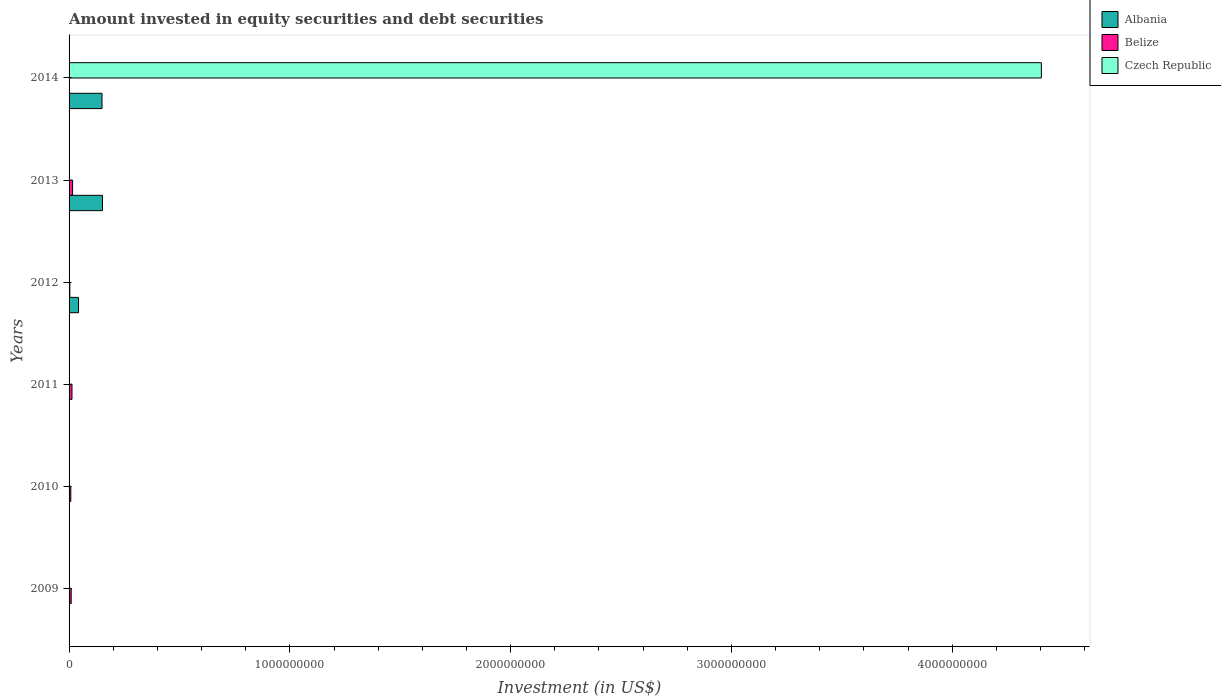Are the number of bars per tick equal to the number of legend labels?
Keep it short and to the point. No. Are the number of bars on each tick of the Y-axis equal?
Ensure brevity in your answer.  No. How many bars are there on the 1st tick from the top?
Make the answer very short. 3. How many bars are there on the 5th tick from the bottom?
Your answer should be compact. 2. What is the label of the 2nd group of bars from the top?
Provide a succinct answer. 2013. What is the amount invested in equity securities and debt securities in Belize in 2011?
Your response must be concise. 1.32e+07. Across all years, what is the maximum amount invested in equity securities and debt securities in Czech Republic?
Provide a succinct answer. 4.40e+09. In which year was the amount invested in equity securities and debt securities in Belize maximum?
Make the answer very short. 2013. What is the total amount invested in equity securities and debt securities in Belize in the graph?
Your answer should be compact. 5.00e+07. What is the difference between the amount invested in equity securities and debt securities in Belize in 2009 and that in 2010?
Your answer should be compact. 1.84e+06. What is the difference between the amount invested in equity securities and debt securities in Albania in 2011 and the amount invested in equity securities and debt securities in Czech Republic in 2013?
Offer a very short reply. 0. What is the average amount invested in equity securities and debt securities in Belize per year?
Offer a very short reply. 8.34e+06. In the year 2014, what is the difference between the amount invested in equity securities and debt securities in Albania and amount invested in equity securities and debt securities in Belize?
Offer a very short reply. 1.49e+08. What is the ratio of the amount invested in equity securities and debt securities in Belize in 2009 to that in 2010?
Provide a succinct answer. 1.24. What is the difference between the highest and the second highest amount invested in equity securities and debt securities in Albania?
Your response must be concise. 2.23e+06. What is the difference between the highest and the lowest amount invested in equity securities and debt securities in Belize?
Give a very brief answer. 1.59e+07. How many years are there in the graph?
Provide a succinct answer. 6. Are the values on the major ticks of X-axis written in scientific E-notation?
Ensure brevity in your answer.  No. Does the graph contain grids?
Make the answer very short. No. How are the legend labels stacked?
Give a very brief answer. Vertical. What is the title of the graph?
Make the answer very short. Amount invested in equity securities and debt securities. Does "Tunisia" appear as one of the legend labels in the graph?
Your answer should be compact. No. What is the label or title of the X-axis?
Make the answer very short. Investment (in US$). What is the Investment (in US$) in Belize in 2009?
Your response must be concise. 9.65e+06. What is the Investment (in US$) of Belize in 2010?
Make the answer very short. 7.81e+06. What is the Investment (in US$) of Czech Republic in 2010?
Ensure brevity in your answer.  0. What is the Investment (in US$) in Belize in 2011?
Make the answer very short. 1.32e+07. What is the Investment (in US$) in Albania in 2012?
Your answer should be compact. 4.29e+07. What is the Investment (in US$) of Belize in 2012?
Offer a terse response. 3.43e+06. What is the Investment (in US$) in Czech Republic in 2012?
Your answer should be very brief. 0. What is the Investment (in US$) of Albania in 2013?
Give a very brief answer. 1.51e+08. What is the Investment (in US$) in Belize in 2013?
Your answer should be very brief. 1.59e+07. What is the Investment (in US$) of Albania in 2014?
Your answer should be compact. 1.49e+08. What is the Investment (in US$) of Belize in 2014?
Your answer should be very brief. 430.6. What is the Investment (in US$) in Czech Republic in 2014?
Ensure brevity in your answer.  4.40e+09. Across all years, what is the maximum Investment (in US$) of Albania?
Offer a very short reply. 1.51e+08. Across all years, what is the maximum Investment (in US$) in Belize?
Your response must be concise. 1.59e+07. Across all years, what is the maximum Investment (in US$) of Czech Republic?
Your answer should be compact. 4.40e+09. Across all years, what is the minimum Investment (in US$) in Belize?
Your response must be concise. 430.6. Across all years, what is the minimum Investment (in US$) of Czech Republic?
Make the answer very short. 0. What is the total Investment (in US$) in Albania in the graph?
Ensure brevity in your answer.  3.44e+08. What is the total Investment (in US$) of Belize in the graph?
Ensure brevity in your answer.  5.00e+07. What is the total Investment (in US$) in Czech Republic in the graph?
Your response must be concise. 4.40e+09. What is the difference between the Investment (in US$) of Belize in 2009 and that in 2010?
Your answer should be very brief. 1.84e+06. What is the difference between the Investment (in US$) of Belize in 2009 and that in 2011?
Keep it short and to the point. -3.54e+06. What is the difference between the Investment (in US$) in Belize in 2009 and that in 2012?
Provide a succinct answer. 6.23e+06. What is the difference between the Investment (in US$) in Belize in 2009 and that in 2013?
Your answer should be very brief. -6.26e+06. What is the difference between the Investment (in US$) in Belize in 2009 and that in 2014?
Provide a short and direct response. 9.65e+06. What is the difference between the Investment (in US$) of Belize in 2010 and that in 2011?
Ensure brevity in your answer.  -5.38e+06. What is the difference between the Investment (in US$) of Belize in 2010 and that in 2012?
Give a very brief answer. 4.39e+06. What is the difference between the Investment (in US$) of Belize in 2010 and that in 2013?
Offer a very short reply. -8.10e+06. What is the difference between the Investment (in US$) of Belize in 2010 and that in 2014?
Ensure brevity in your answer.  7.81e+06. What is the difference between the Investment (in US$) in Belize in 2011 and that in 2012?
Make the answer very short. 9.77e+06. What is the difference between the Investment (in US$) in Belize in 2011 and that in 2013?
Give a very brief answer. -2.72e+06. What is the difference between the Investment (in US$) in Belize in 2011 and that in 2014?
Offer a terse response. 1.32e+07. What is the difference between the Investment (in US$) in Albania in 2012 and that in 2013?
Provide a succinct answer. -1.08e+08. What is the difference between the Investment (in US$) of Belize in 2012 and that in 2013?
Your answer should be very brief. -1.25e+07. What is the difference between the Investment (in US$) of Albania in 2012 and that in 2014?
Give a very brief answer. -1.06e+08. What is the difference between the Investment (in US$) of Belize in 2012 and that in 2014?
Provide a short and direct response. 3.43e+06. What is the difference between the Investment (in US$) in Albania in 2013 and that in 2014?
Give a very brief answer. 2.23e+06. What is the difference between the Investment (in US$) of Belize in 2013 and that in 2014?
Give a very brief answer. 1.59e+07. What is the difference between the Investment (in US$) of Belize in 2009 and the Investment (in US$) of Czech Republic in 2014?
Offer a terse response. -4.39e+09. What is the difference between the Investment (in US$) in Belize in 2010 and the Investment (in US$) in Czech Republic in 2014?
Ensure brevity in your answer.  -4.40e+09. What is the difference between the Investment (in US$) of Belize in 2011 and the Investment (in US$) of Czech Republic in 2014?
Offer a terse response. -4.39e+09. What is the difference between the Investment (in US$) in Albania in 2012 and the Investment (in US$) in Belize in 2013?
Give a very brief answer. 2.70e+07. What is the difference between the Investment (in US$) of Albania in 2012 and the Investment (in US$) of Belize in 2014?
Make the answer very short. 4.29e+07. What is the difference between the Investment (in US$) of Albania in 2012 and the Investment (in US$) of Czech Republic in 2014?
Make the answer very short. -4.36e+09. What is the difference between the Investment (in US$) of Belize in 2012 and the Investment (in US$) of Czech Republic in 2014?
Give a very brief answer. -4.40e+09. What is the difference between the Investment (in US$) in Albania in 2013 and the Investment (in US$) in Belize in 2014?
Your response must be concise. 1.51e+08. What is the difference between the Investment (in US$) in Albania in 2013 and the Investment (in US$) in Czech Republic in 2014?
Your response must be concise. -4.25e+09. What is the difference between the Investment (in US$) of Belize in 2013 and the Investment (in US$) of Czech Republic in 2014?
Provide a succinct answer. -4.39e+09. What is the average Investment (in US$) in Albania per year?
Keep it short and to the point. 5.73e+07. What is the average Investment (in US$) in Belize per year?
Provide a succinct answer. 8.34e+06. What is the average Investment (in US$) of Czech Republic per year?
Your answer should be very brief. 7.34e+08. In the year 2012, what is the difference between the Investment (in US$) in Albania and Investment (in US$) in Belize?
Keep it short and to the point. 3.95e+07. In the year 2013, what is the difference between the Investment (in US$) of Albania and Investment (in US$) of Belize?
Give a very brief answer. 1.35e+08. In the year 2014, what is the difference between the Investment (in US$) in Albania and Investment (in US$) in Belize?
Offer a terse response. 1.49e+08. In the year 2014, what is the difference between the Investment (in US$) in Albania and Investment (in US$) in Czech Republic?
Your answer should be compact. -4.25e+09. In the year 2014, what is the difference between the Investment (in US$) of Belize and Investment (in US$) of Czech Republic?
Ensure brevity in your answer.  -4.40e+09. What is the ratio of the Investment (in US$) in Belize in 2009 to that in 2010?
Offer a very short reply. 1.24. What is the ratio of the Investment (in US$) of Belize in 2009 to that in 2011?
Keep it short and to the point. 0.73. What is the ratio of the Investment (in US$) in Belize in 2009 to that in 2012?
Ensure brevity in your answer.  2.82. What is the ratio of the Investment (in US$) of Belize in 2009 to that in 2013?
Your answer should be compact. 0.61. What is the ratio of the Investment (in US$) of Belize in 2009 to that in 2014?
Your answer should be very brief. 2.24e+04. What is the ratio of the Investment (in US$) in Belize in 2010 to that in 2011?
Offer a terse response. 0.59. What is the ratio of the Investment (in US$) of Belize in 2010 to that in 2012?
Offer a very short reply. 2.28. What is the ratio of the Investment (in US$) of Belize in 2010 to that in 2013?
Give a very brief answer. 0.49. What is the ratio of the Investment (in US$) of Belize in 2010 to that in 2014?
Give a very brief answer. 1.81e+04. What is the ratio of the Investment (in US$) of Belize in 2011 to that in 2012?
Your response must be concise. 3.85. What is the ratio of the Investment (in US$) in Belize in 2011 to that in 2013?
Keep it short and to the point. 0.83. What is the ratio of the Investment (in US$) in Belize in 2011 to that in 2014?
Provide a short and direct response. 3.06e+04. What is the ratio of the Investment (in US$) in Albania in 2012 to that in 2013?
Your response must be concise. 0.28. What is the ratio of the Investment (in US$) in Belize in 2012 to that in 2013?
Ensure brevity in your answer.  0.22. What is the ratio of the Investment (in US$) in Albania in 2012 to that in 2014?
Ensure brevity in your answer.  0.29. What is the ratio of the Investment (in US$) of Belize in 2012 to that in 2014?
Your answer should be compact. 7961.89. What is the ratio of the Investment (in US$) in Albania in 2013 to that in 2014?
Your answer should be compact. 1.01. What is the ratio of the Investment (in US$) of Belize in 2013 to that in 2014?
Make the answer very short. 3.70e+04. What is the difference between the highest and the second highest Investment (in US$) in Albania?
Provide a succinct answer. 2.23e+06. What is the difference between the highest and the second highest Investment (in US$) of Belize?
Keep it short and to the point. 2.72e+06. What is the difference between the highest and the lowest Investment (in US$) in Albania?
Your answer should be very brief. 1.51e+08. What is the difference between the highest and the lowest Investment (in US$) in Belize?
Provide a short and direct response. 1.59e+07. What is the difference between the highest and the lowest Investment (in US$) in Czech Republic?
Ensure brevity in your answer.  4.40e+09. 